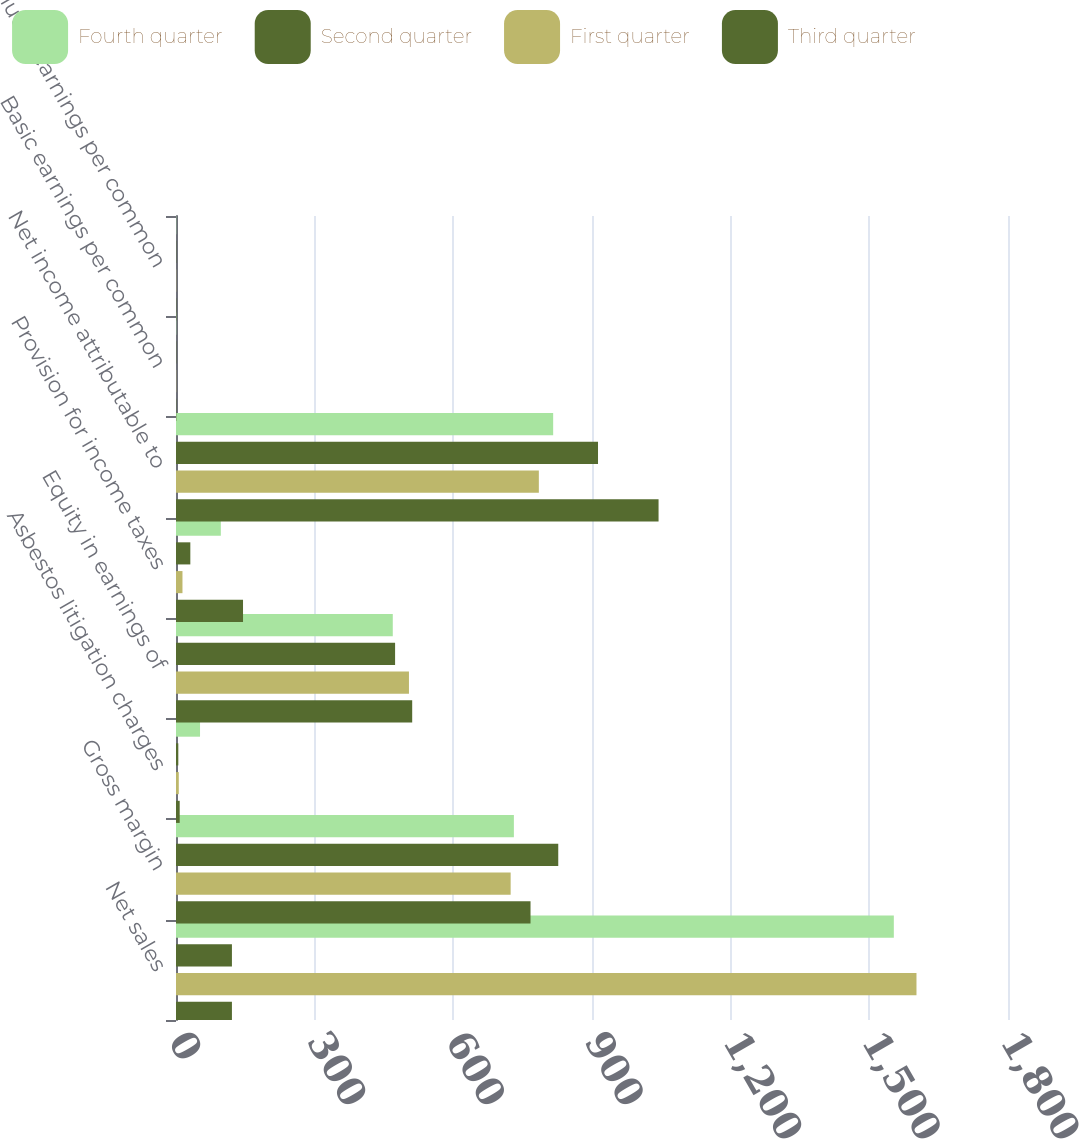Convert chart to OTSL. <chart><loc_0><loc_0><loc_500><loc_500><stacked_bar_chart><ecel><fcel>Net sales<fcel>Gross margin<fcel>Asbestos litigation charges<fcel>Equity in earnings of<fcel>Provision for income taxes<fcel>Net income attributable to<fcel>Basic earnings per common<fcel>Diluted earnings per common<nl><fcel>Fourth quarter<fcel>1553<fcel>731<fcel>52<fcel>469<fcel>97<fcel>816<fcel>0.52<fcel>0.52<nl><fcel>Second quarter<fcel>121<fcel>827<fcel>5<fcel>474<fcel>31<fcel>913<fcel>0.59<fcel>0.58<nl><fcel>First quarter<fcel>1602<fcel>724<fcel>6<fcel>504<fcel>14<fcel>785<fcel>0.5<fcel>0.5<nl><fcel>Third quarter<fcel>121<fcel>767<fcel>8<fcel>511<fcel>145<fcel>1044<fcel>0.67<fcel>0.66<nl></chart> 